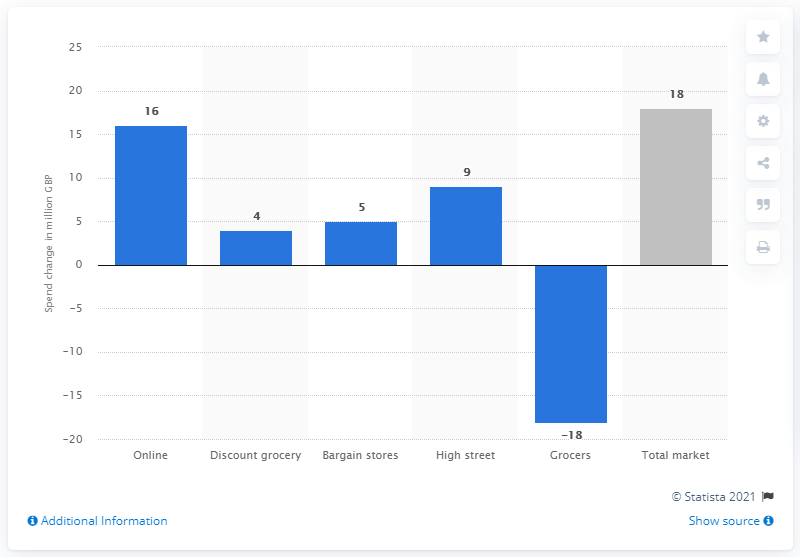Point out several critical features in this image. The spending in grocers' main stores decreased by 18% in the last quarter of 2013. The overall spending in the health and beauty market grew by 18% in the last quarter of 2013. 